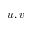Convert formula to latex. <formula><loc_0><loc_0><loc_500><loc_500>u , v</formula> 